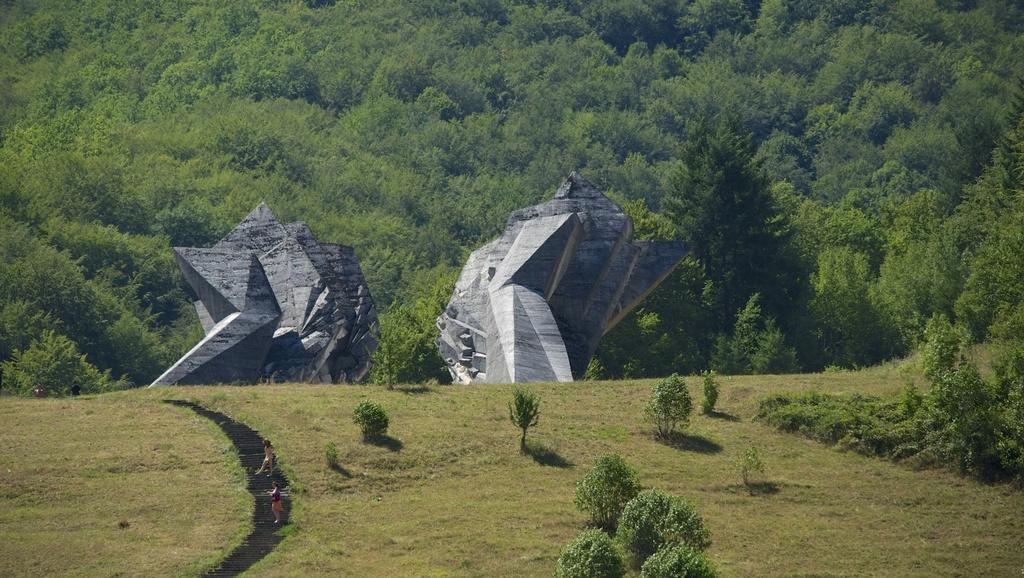How many people are in the image? There are two persons standing in the image. What can be seen in the background of the image? There are huge carved rocks in the background of the image. What type of vegetation is present in the image? There are trees with green color in the image. What is the scent of the connection between the two persons in the image? There is no mention of a connection or scent in the image; it only shows two persons standing and the background with carved rocks and green trees. 